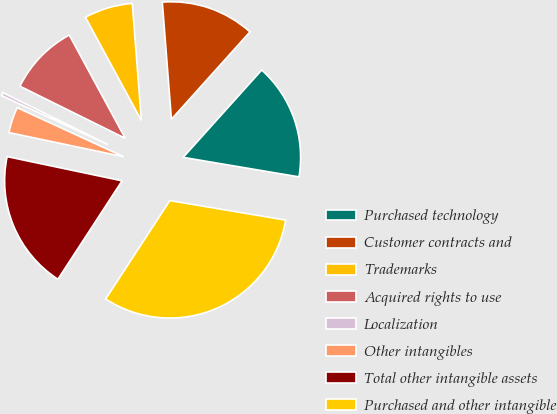Convert chart. <chart><loc_0><loc_0><loc_500><loc_500><pie_chart><fcel>Purchased technology<fcel>Customer contracts and<fcel>Trademarks<fcel>Acquired rights to use<fcel>Localization<fcel>Other intangibles<fcel>Total other intangible assets<fcel>Purchased and other intangible<nl><fcel>16.0%<fcel>12.89%<fcel>6.67%<fcel>9.78%<fcel>0.45%<fcel>3.56%<fcel>19.11%<fcel>31.54%<nl></chart> 